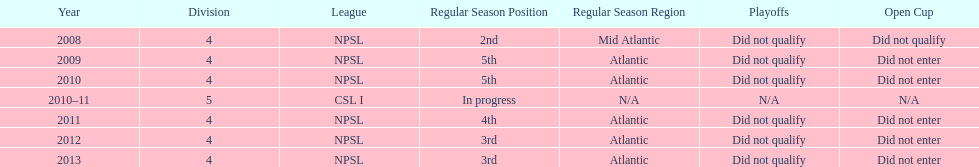Other than npsl, what league has ny mens soccer team played in? CSL I. 